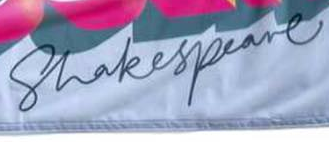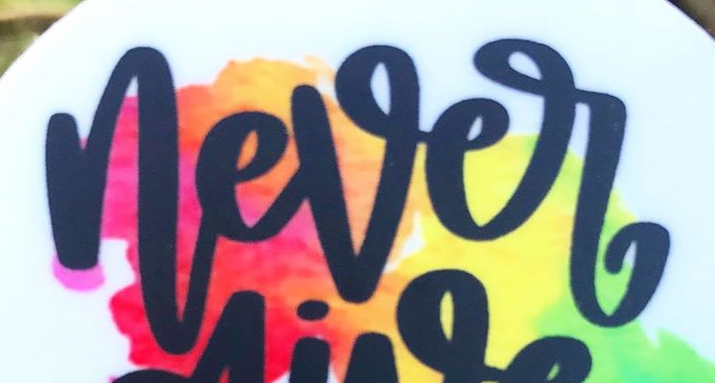What text is displayed in these images sequentially, separated by a semicolon? Shakespeare; never 